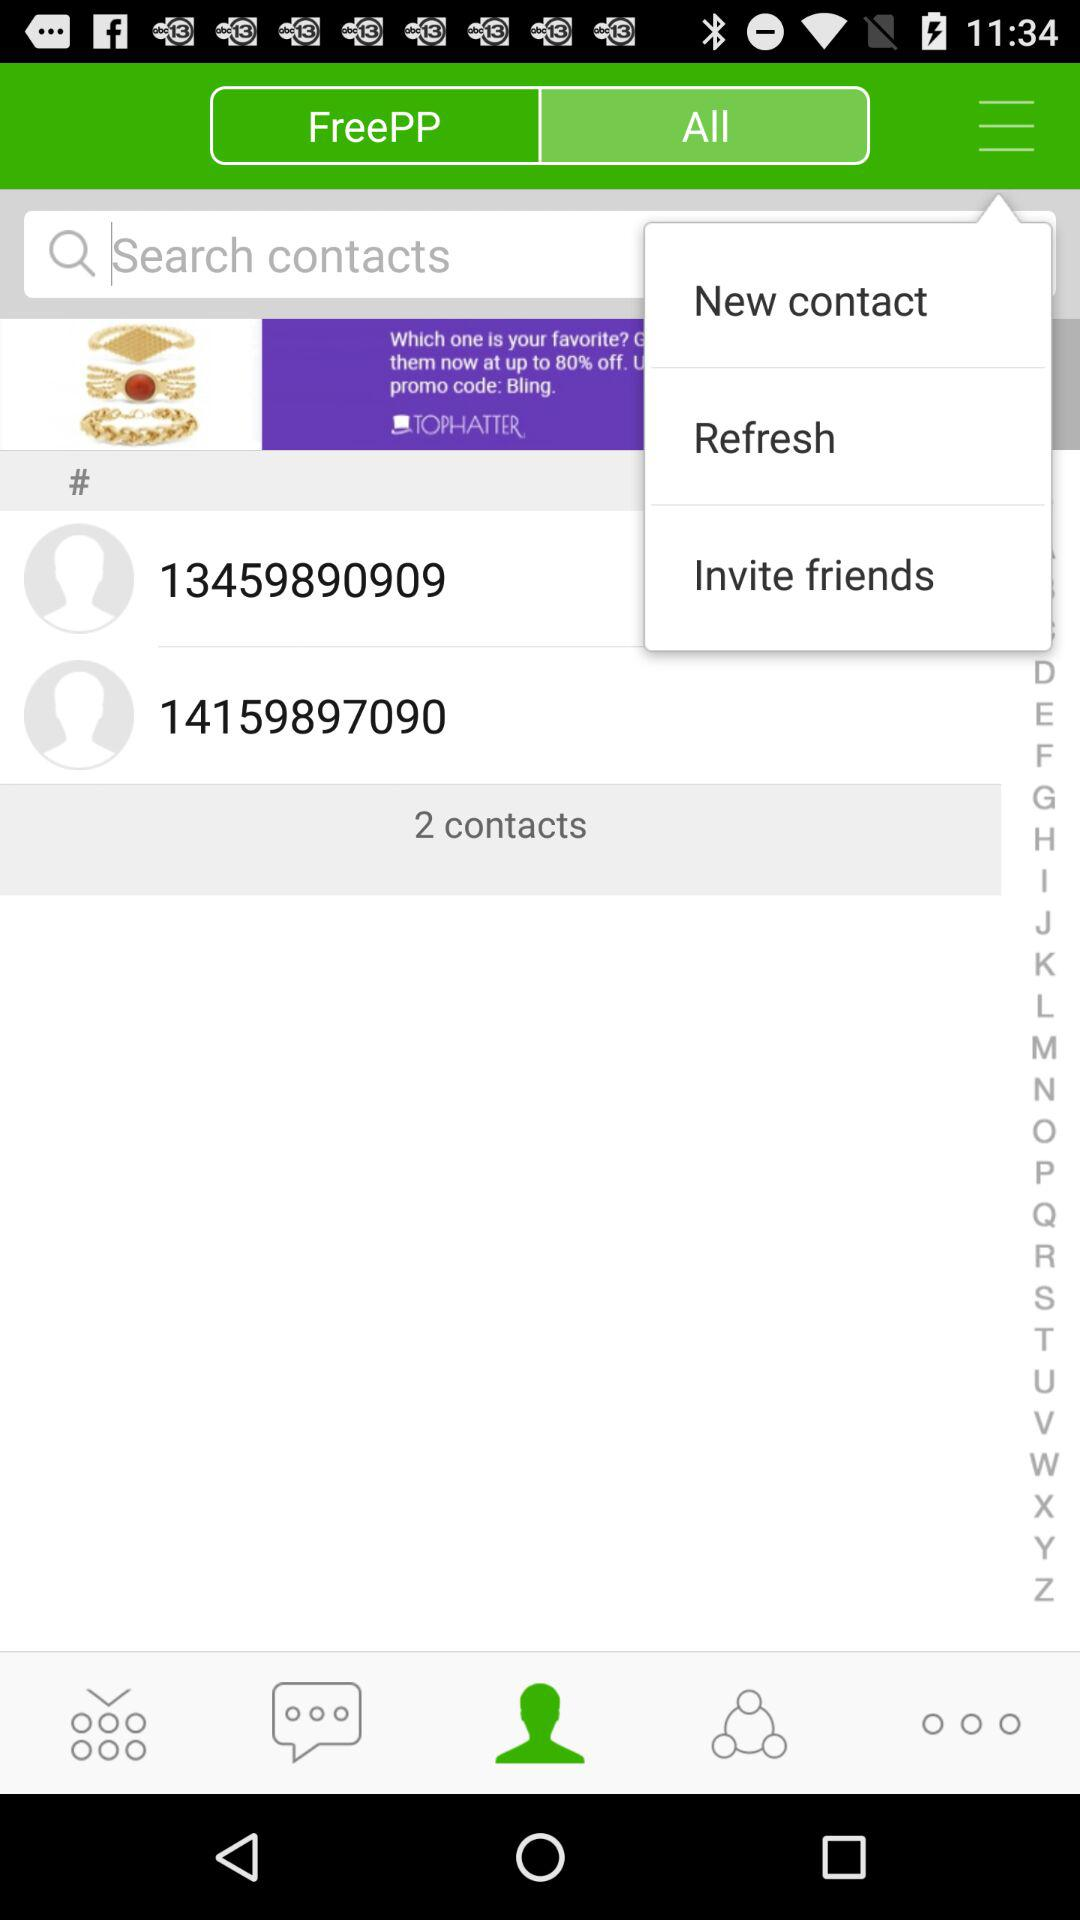Which tab is selected? The selected tabs are "Contacts" and "All". 